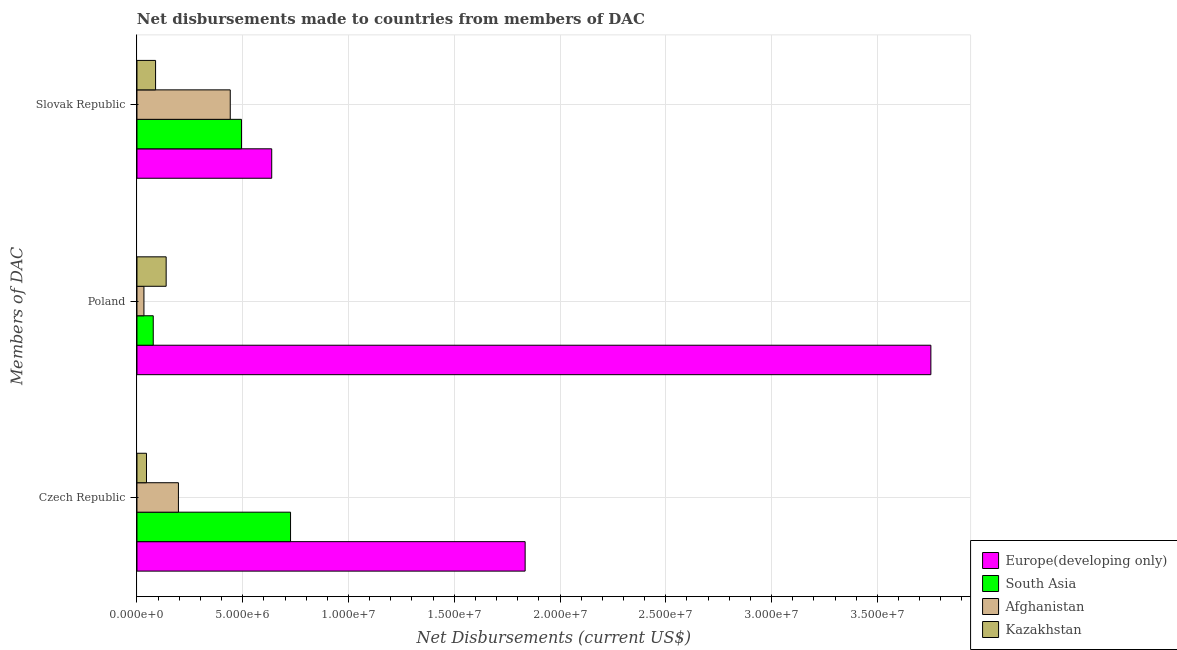Are the number of bars per tick equal to the number of legend labels?
Give a very brief answer. Yes. What is the net disbursements made by czech republic in Kazakhstan?
Your response must be concise. 4.50e+05. Across all countries, what is the maximum net disbursements made by poland?
Keep it short and to the point. 3.75e+07. Across all countries, what is the minimum net disbursements made by czech republic?
Provide a short and direct response. 4.50e+05. In which country was the net disbursements made by czech republic maximum?
Your answer should be compact. Europe(developing only). In which country was the net disbursements made by czech republic minimum?
Your answer should be very brief. Kazakhstan. What is the total net disbursements made by czech republic in the graph?
Make the answer very short. 2.80e+07. What is the difference between the net disbursements made by czech republic in Afghanistan and that in Europe(developing only)?
Make the answer very short. -1.64e+07. What is the difference between the net disbursements made by slovak republic in Europe(developing only) and the net disbursements made by czech republic in Kazakhstan?
Your response must be concise. 5.92e+06. What is the average net disbursements made by czech republic per country?
Make the answer very short. 7.00e+06. What is the difference between the net disbursements made by slovak republic and net disbursements made by poland in Kazakhstan?
Make the answer very short. -5.00e+05. What is the ratio of the net disbursements made by slovak republic in Afghanistan to that in Kazakhstan?
Provide a succinct answer. 5.01. Is the net disbursements made by poland in Europe(developing only) less than that in Kazakhstan?
Your response must be concise. No. What is the difference between the highest and the second highest net disbursements made by poland?
Provide a succinct answer. 3.62e+07. What is the difference between the highest and the lowest net disbursements made by slovak republic?
Provide a short and direct response. 5.49e+06. What does the 1st bar from the top in Poland represents?
Your answer should be compact. Kazakhstan. Is it the case that in every country, the sum of the net disbursements made by czech republic and net disbursements made by poland is greater than the net disbursements made by slovak republic?
Your answer should be very brief. No. How many bars are there?
Your response must be concise. 12. Are all the bars in the graph horizontal?
Provide a short and direct response. Yes. Does the graph contain any zero values?
Offer a very short reply. No. What is the title of the graph?
Provide a short and direct response. Net disbursements made to countries from members of DAC. What is the label or title of the X-axis?
Give a very brief answer. Net Disbursements (current US$). What is the label or title of the Y-axis?
Your answer should be very brief. Members of DAC. What is the Net Disbursements (current US$) in Europe(developing only) in Czech Republic?
Make the answer very short. 1.84e+07. What is the Net Disbursements (current US$) of South Asia in Czech Republic?
Provide a succinct answer. 7.26e+06. What is the Net Disbursements (current US$) in Afghanistan in Czech Republic?
Your answer should be compact. 1.96e+06. What is the Net Disbursements (current US$) in Europe(developing only) in Poland?
Make the answer very short. 3.75e+07. What is the Net Disbursements (current US$) of South Asia in Poland?
Your answer should be compact. 7.70e+05. What is the Net Disbursements (current US$) of Afghanistan in Poland?
Your answer should be compact. 3.30e+05. What is the Net Disbursements (current US$) in Kazakhstan in Poland?
Offer a terse response. 1.38e+06. What is the Net Disbursements (current US$) in Europe(developing only) in Slovak Republic?
Offer a terse response. 6.37e+06. What is the Net Disbursements (current US$) of South Asia in Slovak Republic?
Provide a succinct answer. 4.94e+06. What is the Net Disbursements (current US$) in Afghanistan in Slovak Republic?
Make the answer very short. 4.41e+06. What is the Net Disbursements (current US$) of Kazakhstan in Slovak Republic?
Ensure brevity in your answer.  8.80e+05. Across all Members of DAC, what is the maximum Net Disbursements (current US$) in Europe(developing only)?
Provide a succinct answer. 3.75e+07. Across all Members of DAC, what is the maximum Net Disbursements (current US$) in South Asia?
Keep it short and to the point. 7.26e+06. Across all Members of DAC, what is the maximum Net Disbursements (current US$) in Afghanistan?
Make the answer very short. 4.41e+06. Across all Members of DAC, what is the maximum Net Disbursements (current US$) in Kazakhstan?
Provide a succinct answer. 1.38e+06. Across all Members of DAC, what is the minimum Net Disbursements (current US$) in Europe(developing only)?
Your answer should be very brief. 6.37e+06. Across all Members of DAC, what is the minimum Net Disbursements (current US$) of South Asia?
Keep it short and to the point. 7.70e+05. What is the total Net Disbursements (current US$) of Europe(developing only) in the graph?
Provide a succinct answer. 6.22e+07. What is the total Net Disbursements (current US$) of South Asia in the graph?
Offer a terse response. 1.30e+07. What is the total Net Disbursements (current US$) in Afghanistan in the graph?
Offer a very short reply. 6.70e+06. What is the total Net Disbursements (current US$) in Kazakhstan in the graph?
Offer a terse response. 2.71e+06. What is the difference between the Net Disbursements (current US$) in Europe(developing only) in Czech Republic and that in Poland?
Ensure brevity in your answer.  -1.92e+07. What is the difference between the Net Disbursements (current US$) in South Asia in Czech Republic and that in Poland?
Ensure brevity in your answer.  6.49e+06. What is the difference between the Net Disbursements (current US$) in Afghanistan in Czech Republic and that in Poland?
Make the answer very short. 1.63e+06. What is the difference between the Net Disbursements (current US$) of Kazakhstan in Czech Republic and that in Poland?
Keep it short and to the point. -9.30e+05. What is the difference between the Net Disbursements (current US$) in Europe(developing only) in Czech Republic and that in Slovak Republic?
Keep it short and to the point. 1.20e+07. What is the difference between the Net Disbursements (current US$) of South Asia in Czech Republic and that in Slovak Republic?
Your response must be concise. 2.32e+06. What is the difference between the Net Disbursements (current US$) in Afghanistan in Czech Republic and that in Slovak Republic?
Provide a short and direct response. -2.45e+06. What is the difference between the Net Disbursements (current US$) of Kazakhstan in Czech Republic and that in Slovak Republic?
Offer a terse response. -4.30e+05. What is the difference between the Net Disbursements (current US$) of Europe(developing only) in Poland and that in Slovak Republic?
Ensure brevity in your answer.  3.12e+07. What is the difference between the Net Disbursements (current US$) in South Asia in Poland and that in Slovak Republic?
Your answer should be very brief. -4.17e+06. What is the difference between the Net Disbursements (current US$) of Afghanistan in Poland and that in Slovak Republic?
Provide a short and direct response. -4.08e+06. What is the difference between the Net Disbursements (current US$) of Kazakhstan in Poland and that in Slovak Republic?
Offer a very short reply. 5.00e+05. What is the difference between the Net Disbursements (current US$) of Europe(developing only) in Czech Republic and the Net Disbursements (current US$) of South Asia in Poland?
Your answer should be very brief. 1.76e+07. What is the difference between the Net Disbursements (current US$) of Europe(developing only) in Czech Republic and the Net Disbursements (current US$) of Afghanistan in Poland?
Give a very brief answer. 1.80e+07. What is the difference between the Net Disbursements (current US$) in Europe(developing only) in Czech Republic and the Net Disbursements (current US$) in Kazakhstan in Poland?
Offer a terse response. 1.70e+07. What is the difference between the Net Disbursements (current US$) of South Asia in Czech Republic and the Net Disbursements (current US$) of Afghanistan in Poland?
Your answer should be very brief. 6.93e+06. What is the difference between the Net Disbursements (current US$) of South Asia in Czech Republic and the Net Disbursements (current US$) of Kazakhstan in Poland?
Provide a short and direct response. 5.88e+06. What is the difference between the Net Disbursements (current US$) of Afghanistan in Czech Republic and the Net Disbursements (current US$) of Kazakhstan in Poland?
Make the answer very short. 5.80e+05. What is the difference between the Net Disbursements (current US$) in Europe(developing only) in Czech Republic and the Net Disbursements (current US$) in South Asia in Slovak Republic?
Ensure brevity in your answer.  1.34e+07. What is the difference between the Net Disbursements (current US$) of Europe(developing only) in Czech Republic and the Net Disbursements (current US$) of Afghanistan in Slovak Republic?
Provide a succinct answer. 1.39e+07. What is the difference between the Net Disbursements (current US$) in Europe(developing only) in Czech Republic and the Net Disbursements (current US$) in Kazakhstan in Slovak Republic?
Ensure brevity in your answer.  1.75e+07. What is the difference between the Net Disbursements (current US$) in South Asia in Czech Republic and the Net Disbursements (current US$) in Afghanistan in Slovak Republic?
Provide a short and direct response. 2.85e+06. What is the difference between the Net Disbursements (current US$) of South Asia in Czech Republic and the Net Disbursements (current US$) of Kazakhstan in Slovak Republic?
Ensure brevity in your answer.  6.38e+06. What is the difference between the Net Disbursements (current US$) in Afghanistan in Czech Republic and the Net Disbursements (current US$) in Kazakhstan in Slovak Republic?
Your answer should be very brief. 1.08e+06. What is the difference between the Net Disbursements (current US$) in Europe(developing only) in Poland and the Net Disbursements (current US$) in South Asia in Slovak Republic?
Your answer should be very brief. 3.26e+07. What is the difference between the Net Disbursements (current US$) in Europe(developing only) in Poland and the Net Disbursements (current US$) in Afghanistan in Slovak Republic?
Make the answer very short. 3.31e+07. What is the difference between the Net Disbursements (current US$) in Europe(developing only) in Poland and the Net Disbursements (current US$) in Kazakhstan in Slovak Republic?
Offer a very short reply. 3.66e+07. What is the difference between the Net Disbursements (current US$) in South Asia in Poland and the Net Disbursements (current US$) in Afghanistan in Slovak Republic?
Your answer should be compact. -3.64e+06. What is the difference between the Net Disbursements (current US$) of Afghanistan in Poland and the Net Disbursements (current US$) of Kazakhstan in Slovak Republic?
Make the answer very short. -5.50e+05. What is the average Net Disbursements (current US$) in Europe(developing only) per Members of DAC?
Your response must be concise. 2.08e+07. What is the average Net Disbursements (current US$) in South Asia per Members of DAC?
Make the answer very short. 4.32e+06. What is the average Net Disbursements (current US$) in Afghanistan per Members of DAC?
Offer a very short reply. 2.23e+06. What is the average Net Disbursements (current US$) of Kazakhstan per Members of DAC?
Provide a succinct answer. 9.03e+05. What is the difference between the Net Disbursements (current US$) in Europe(developing only) and Net Disbursements (current US$) in South Asia in Czech Republic?
Your answer should be very brief. 1.11e+07. What is the difference between the Net Disbursements (current US$) in Europe(developing only) and Net Disbursements (current US$) in Afghanistan in Czech Republic?
Offer a very short reply. 1.64e+07. What is the difference between the Net Disbursements (current US$) in Europe(developing only) and Net Disbursements (current US$) in Kazakhstan in Czech Republic?
Make the answer very short. 1.79e+07. What is the difference between the Net Disbursements (current US$) of South Asia and Net Disbursements (current US$) of Afghanistan in Czech Republic?
Offer a terse response. 5.30e+06. What is the difference between the Net Disbursements (current US$) in South Asia and Net Disbursements (current US$) in Kazakhstan in Czech Republic?
Provide a short and direct response. 6.81e+06. What is the difference between the Net Disbursements (current US$) in Afghanistan and Net Disbursements (current US$) in Kazakhstan in Czech Republic?
Offer a terse response. 1.51e+06. What is the difference between the Net Disbursements (current US$) in Europe(developing only) and Net Disbursements (current US$) in South Asia in Poland?
Your answer should be very brief. 3.68e+07. What is the difference between the Net Disbursements (current US$) of Europe(developing only) and Net Disbursements (current US$) of Afghanistan in Poland?
Provide a short and direct response. 3.72e+07. What is the difference between the Net Disbursements (current US$) in Europe(developing only) and Net Disbursements (current US$) in Kazakhstan in Poland?
Your answer should be very brief. 3.62e+07. What is the difference between the Net Disbursements (current US$) in South Asia and Net Disbursements (current US$) in Afghanistan in Poland?
Provide a short and direct response. 4.40e+05. What is the difference between the Net Disbursements (current US$) of South Asia and Net Disbursements (current US$) of Kazakhstan in Poland?
Make the answer very short. -6.10e+05. What is the difference between the Net Disbursements (current US$) of Afghanistan and Net Disbursements (current US$) of Kazakhstan in Poland?
Provide a succinct answer. -1.05e+06. What is the difference between the Net Disbursements (current US$) in Europe(developing only) and Net Disbursements (current US$) in South Asia in Slovak Republic?
Your response must be concise. 1.43e+06. What is the difference between the Net Disbursements (current US$) of Europe(developing only) and Net Disbursements (current US$) of Afghanistan in Slovak Republic?
Provide a short and direct response. 1.96e+06. What is the difference between the Net Disbursements (current US$) of Europe(developing only) and Net Disbursements (current US$) of Kazakhstan in Slovak Republic?
Ensure brevity in your answer.  5.49e+06. What is the difference between the Net Disbursements (current US$) of South Asia and Net Disbursements (current US$) of Afghanistan in Slovak Republic?
Provide a short and direct response. 5.30e+05. What is the difference between the Net Disbursements (current US$) of South Asia and Net Disbursements (current US$) of Kazakhstan in Slovak Republic?
Make the answer very short. 4.06e+06. What is the difference between the Net Disbursements (current US$) of Afghanistan and Net Disbursements (current US$) of Kazakhstan in Slovak Republic?
Offer a terse response. 3.53e+06. What is the ratio of the Net Disbursements (current US$) of Europe(developing only) in Czech Republic to that in Poland?
Make the answer very short. 0.49. What is the ratio of the Net Disbursements (current US$) of South Asia in Czech Republic to that in Poland?
Your answer should be very brief. 9.43. What is the ratio of the Net Disbursements (current US$) in Afghanistan in Czech Republic to that in Poland?
Offer a terse response. 5.94. What is the ratio of the Net Disbursements (current US$) of Kazakhstan in Czech Republic to that in Poland?
Make the answer very short. 0.33. What is the ratio of the Net Disbursements (current US$) in Europe(developing only) in Czech Republic to that in Slovak Republic?
Offer a terse response. 2.88. What is the ratio of the Net Disbursements (current US$) in South Asia in Czech Republic to that in Slovak Republic?
Your answer should be very brief. 1.47. What is the ratio of the Net Disbursements (current US$) in Afghanistan in Czech Republic to that in Slovak Republic?
Provide a short and direct response. 0.44. What is the ratio of the Net Disbursements (current US$) in Kazakhstan in Czech Republic to that in Slovak Republic?
Make the answer very short. 0.51. What is the ratio of the Net Disbursements (current US$) of Europe(developing only) in Poland to that in Slovak Republic?
Your answer should be very brief. 5.89. What is the ratio of the Net Disbursements (current US$) in South Asia in Poland to that in Slovak Republic?
Provide a succinct answer. 0.16. What is the ratio of the Net Disbursements (current US$) in Afghanistan in Poland to that in Slovak Republic?
Offer a terse response. 0.07. What is the ratio of the Net Disbursements (current US$) of Kazakhstan in Poland to that in Slovak Republic?
Your answer should be very brief. 1.57. What is the difference between the highest and the second highest Net Disbursements (current US$) of Europe(developing only)?
Ensure brevity in your answer.  1.92e+07. What is the difference between the highest and the second highest Net Disbursements (current US$) in South Asia?
Give a very brief answer. 2.32e+06. What is the difference between the highest and the second highest Net Disbursements (current US$) in Afghanistan?
Give a very brief answer. 2.45e+06. What is the difference between the highest and the second highest Net Disbursements (current US$) of Kazakhstan?
Ensure brevity in your answer.  5.00e+05. What is the difference between the highest and the lowest Net Disbursements (current US$) in Europe(developing only)?
Your answer should be very brief. 3.12e+07. What is the difference between the highest and the lowest Net Disbursements (current US$) of South Asia?
Keep it short and to the point. 6.49e+06. What is the difference between the highest and the lowest Net Disbursements (current US$) of Afghanistan?
Your answer should be very brief. 4.08e+06. What is the difference between the highest and the lowest Net Disbursements (current US$) of Kazakhstan?
Your response must be concise. 9.30e+05. 